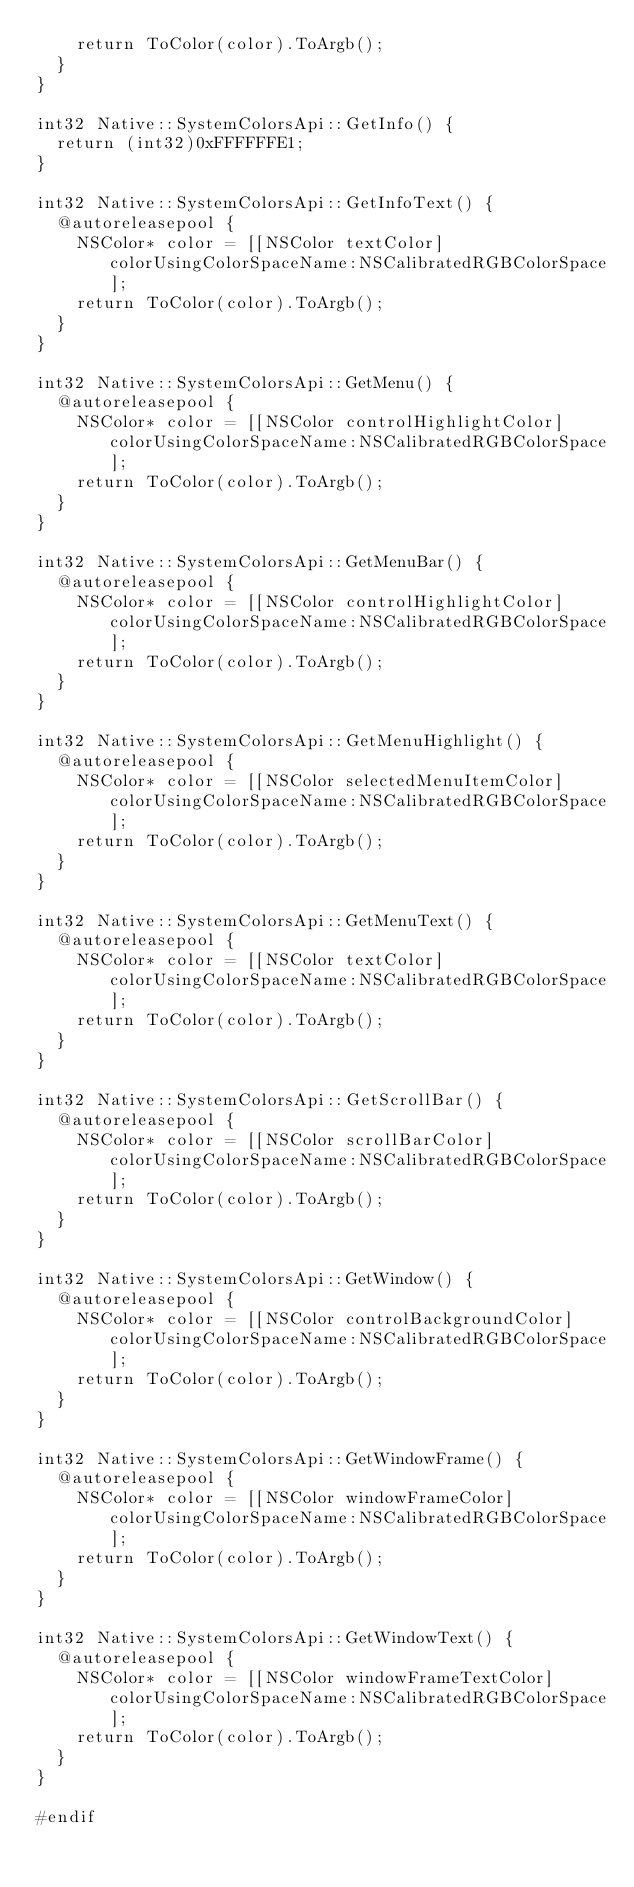Convert code to text. <code><loc_0><loc_0><loc_500><loc_500><_ObjectiveC_>    return ToColor(color).ToArgb();
  }
}

int32 Native::SystemColorsApi::GetInfo() {
  return (int32)0xFFFFFFE1;
}

int32 Native::SystemColorsApi::GetInfoText() {
  @autoreleasepool {
    NSColor* color = [[NSColor textColor] colorUsingColorSpaceName:NSCalibratedRGBColorSpace];
    return ToColor(color).ToArgb();
  }
}

int32 Native::SystemColorsApi::GetMenu() {
  @autoreleasepool {
    NSColor* color = [[NSColor controlHighlightColor] colorUsingColorSpaceName:NSCalibratedRGBColorSpace];
    return ToColor(color).ToArgb();
  }
}

int32 Native::SystemColorsApi::GetMenuBar() {
  @autoreleasepool {
    NSColor* color = [[NSColor controlHighlightColor] colorUsingColorSpaceName:NSCalibratedRGBColorSpace];
    return ToColor(color).ToArgb();
  }
}

int32 Native::SystemColorsApi::GetMenuHighlight() {
  @autoreleasepool {
    NSColor* color = [[NSColor selectedMenuItemColor] colorUsingColorSpaceName:NSCalibratedRGBColorSpace];
    return ToColor(color).ToArgb();
  }
}

int32 Native::SystemColorsApi::GetMenuText() {
  @autoreleasepool {
    NSColor* color = [[NSColor textColor] colorUsingColorSpaceName:NSCalibratedRGBColorSpace];
    return ToColor(color).ToArgb();
  }
}

int32 Native::SystemColorsApi::GetScrollBar() {
  @autoreleasepool {
    NSColor* color = [[NSColor scrollBarColor] colorUsingColorSpaceName:NSCalibratedRGBColorSpace];
    return ToColor(color).ToArgb();
  }
}

int32 Native::SystemColorsApi::GetWindow() {
  @autoreleasepool {
    NSColor* color = [[NSColor controlBackgroundColor] colorUsingColorSpaceName:NSCalibratedRGBColorSpace];
    return ToColor(color).ToArgb();
  }
}

int32 Native::SystemColorsApi::GetWindowFrame() {
  @autoreleasepool {
    NSColor* color = [[NSColor windowFrameColor] colorUsingColorSpaceName:NSCalibratedRGBColorSpace];
    return ToColor(color).ToArgb();
  }
}

int32 Native::SystemColorsApi::GetWindowText() {
  @autoreleasepool {
    NSColor* color = [[NSColor windowFrameTextColor] colorUsingColorSpaceName:NSCalibratedRGBColorSpace];
    return ToColor(color).ToArgb();
  }
}

#endif
</code> 